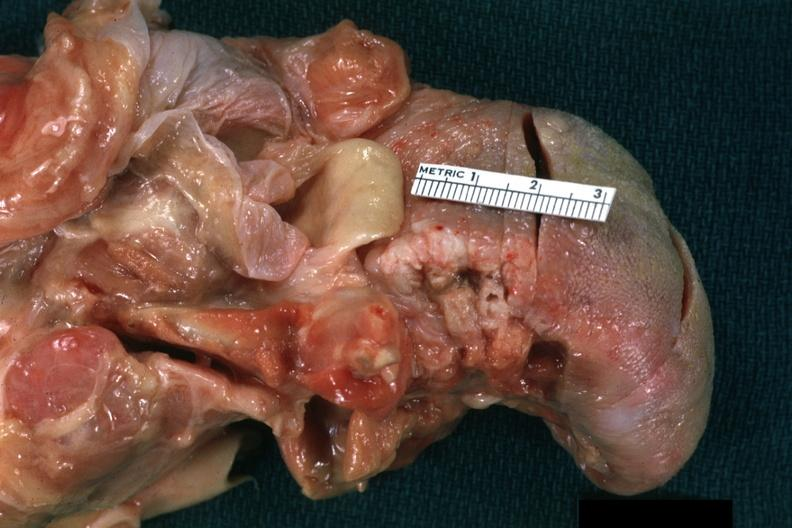what is present?
Answer the question using a single word or phrase. Squamous cell carcinoma 